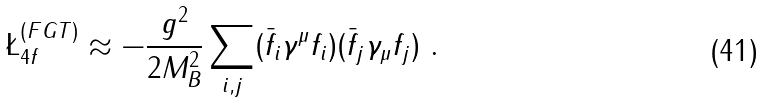Convert formula to latex. <formula><loc_0><loc_0><loc_500><loc_500>\L ^ { ( F G T ) } _ { 4 f } \approx - \frac { g ^ { 2 } } { 2 M _ { B } ^ { 2 } } \sum _ { i , j } ( \bar { f } _ { i } \gamma ^ { \mu } f _ { i } ) ( \bar { f } _ { j } \gamma _ { \mu } f _ { j } ) \ .</formula> 